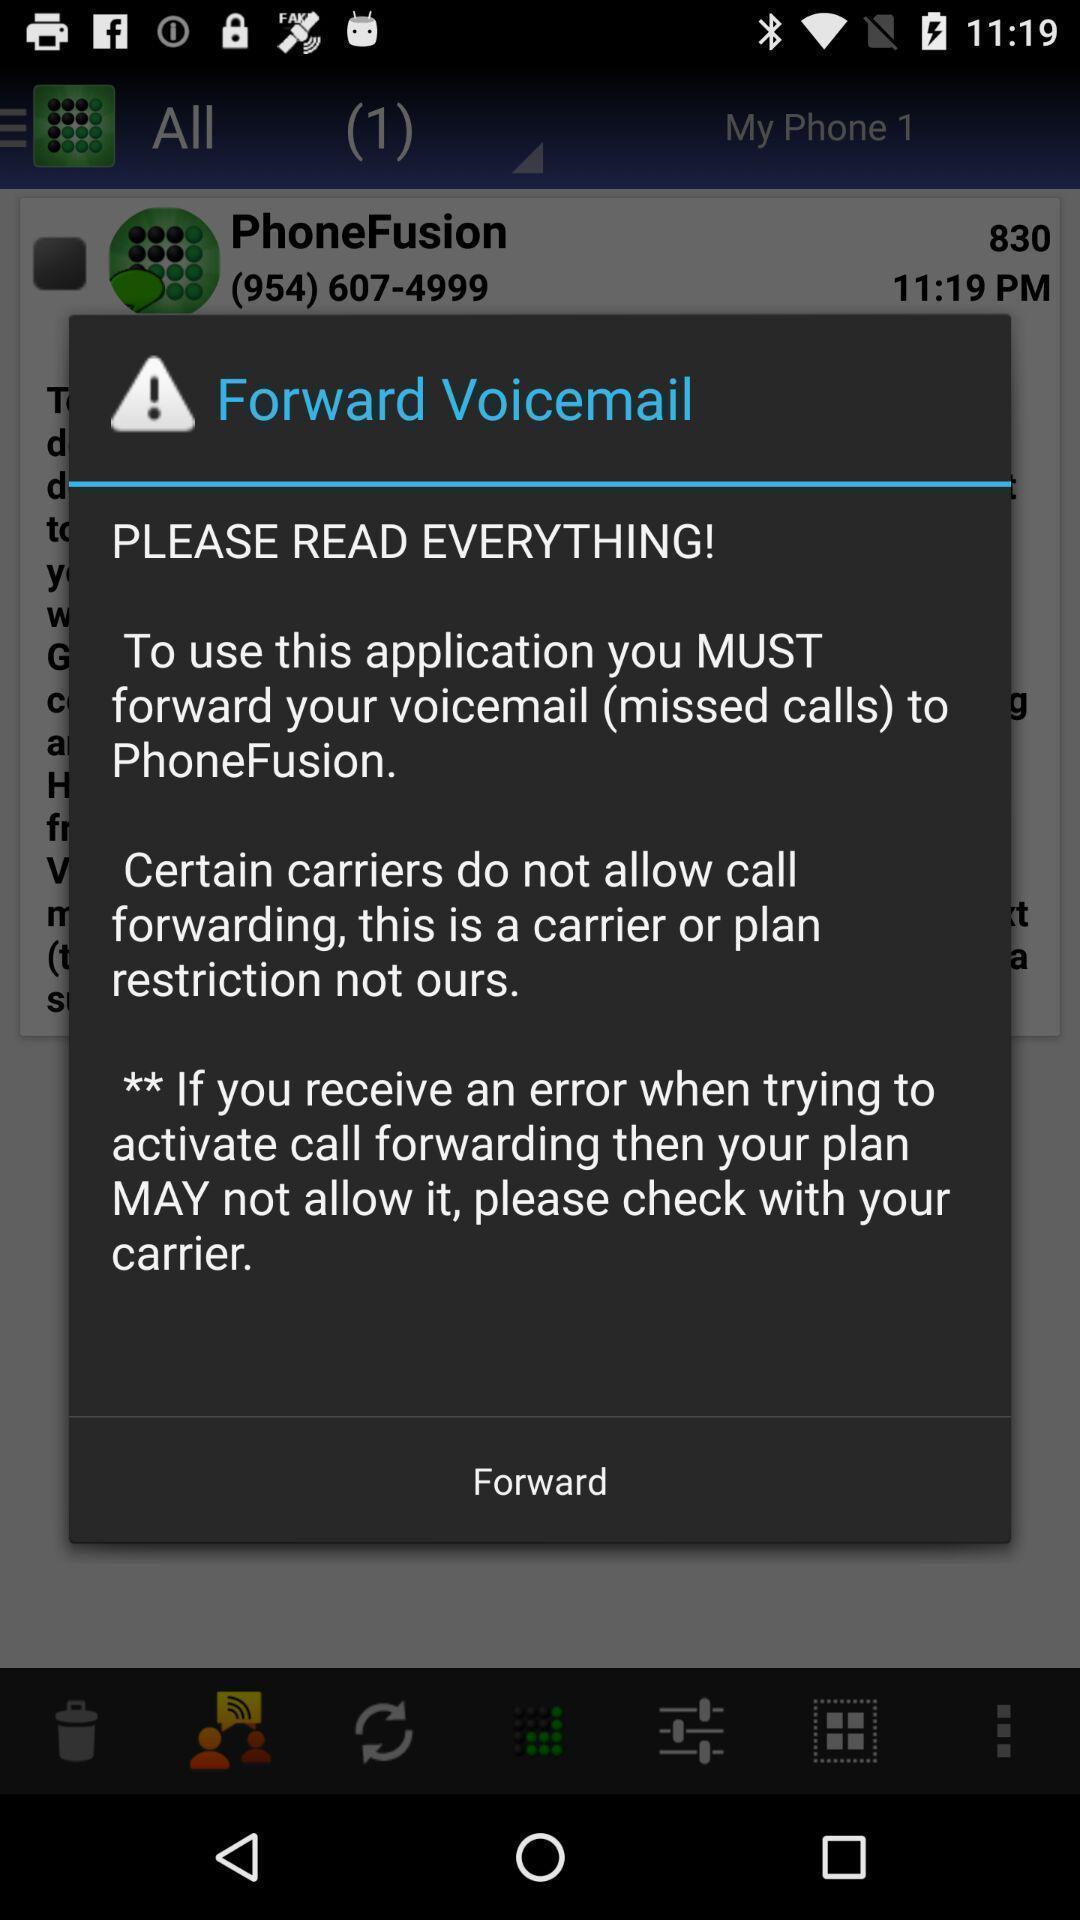Provide a textual representation of this image. Pop-up showing forward warning message. 